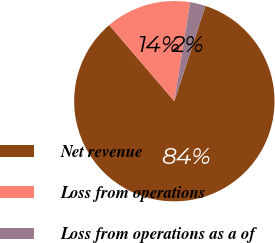Convert chart to OTSL. <chart><loc_0><loc_0><loc_500><loc_500><pie_chart><fcel>Net revenue<fcel>Loss from operations<fcel>Loss from operations as a of<nl><fcel>83.72%<fcel>13.78%<fcel>2.5%<nl></chart> 